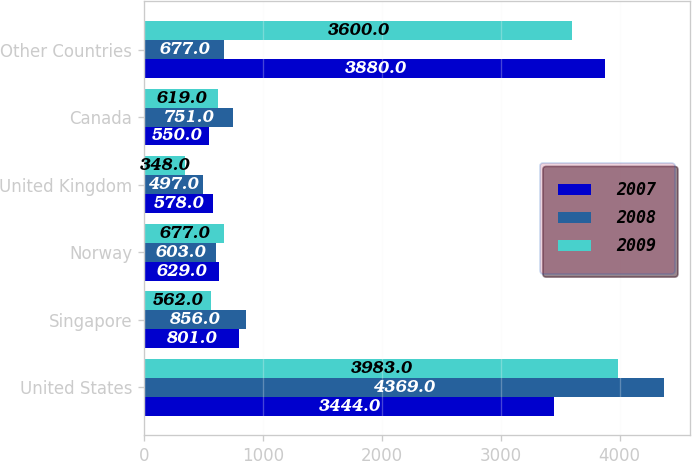Convert chart to OTSL. <chart><loc_0><loc_0><loc_500><loc_500><stacked_bar_chart><ecel><fcel>United States<fcel>Singapore<fcel>Norway<fcel>United Kingdom<fcel>Canada<fcel>Other Countries<nl><fcel>2007<fcel>3444<fcel>801<fcel>629<fcel>578<fcel>550<fcel>3880<nl><fcel>2008<fcel>4369<fcel>856<fcel>603<fcel>497<fcel>751<fcel>677<nl><fcel>2009<fcel>3983<fcel>562<fcel>677<fcel>348<fcel>619<fcel>3600<nl></chart> 